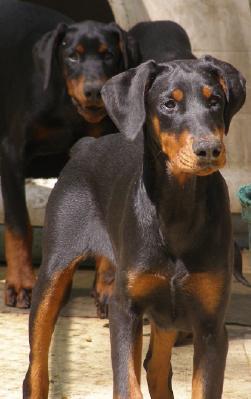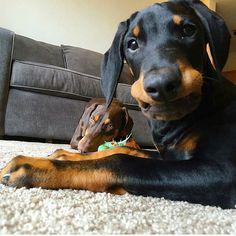The first image is the image on the left, the second image is the image on the right. Assess this claim about the two images: "There is a total of two real dogs.". Correct or not? Answer yes or no. No. The first image is the image on the left, the second image is the image on the right. Analyze the images presented: Is the assertion "There are exactly two dogs." valid? Answer yes or no. No. 